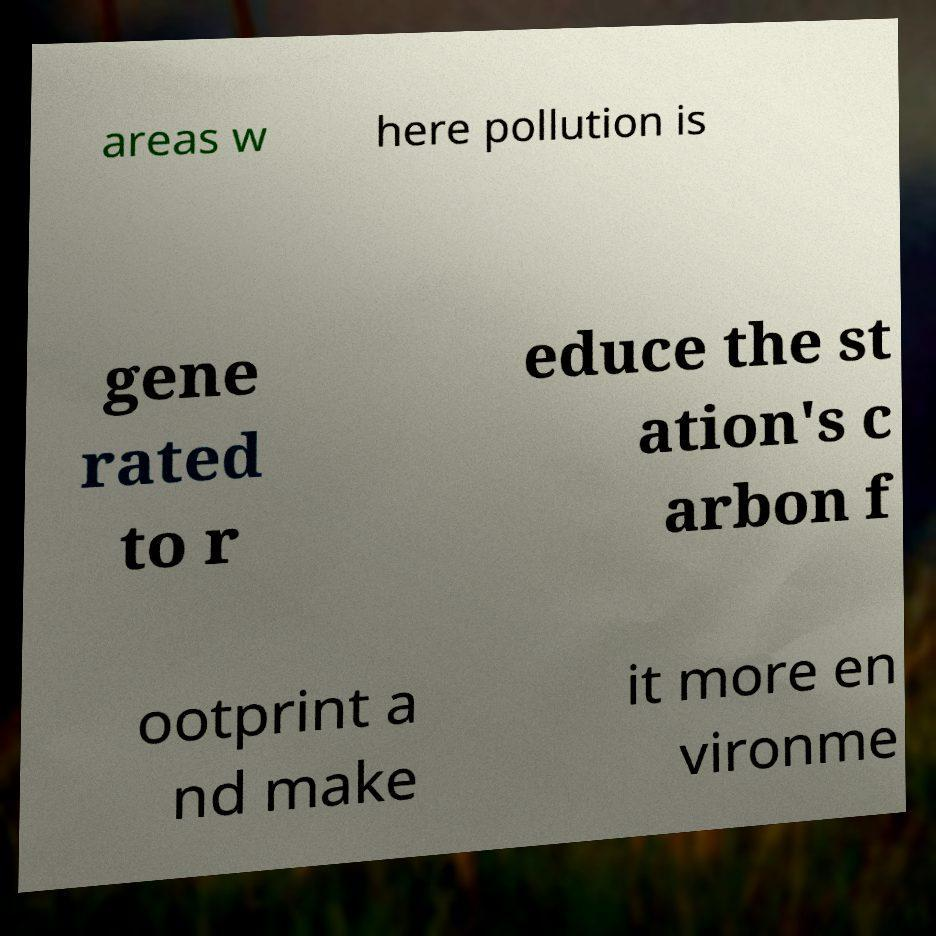For documentation purposes, I need the text within this image transcribed. Could you provide that? areas w here pollution is gene rated to r educe the st ation's c arbon f ootprint a nd make it more en vironme 